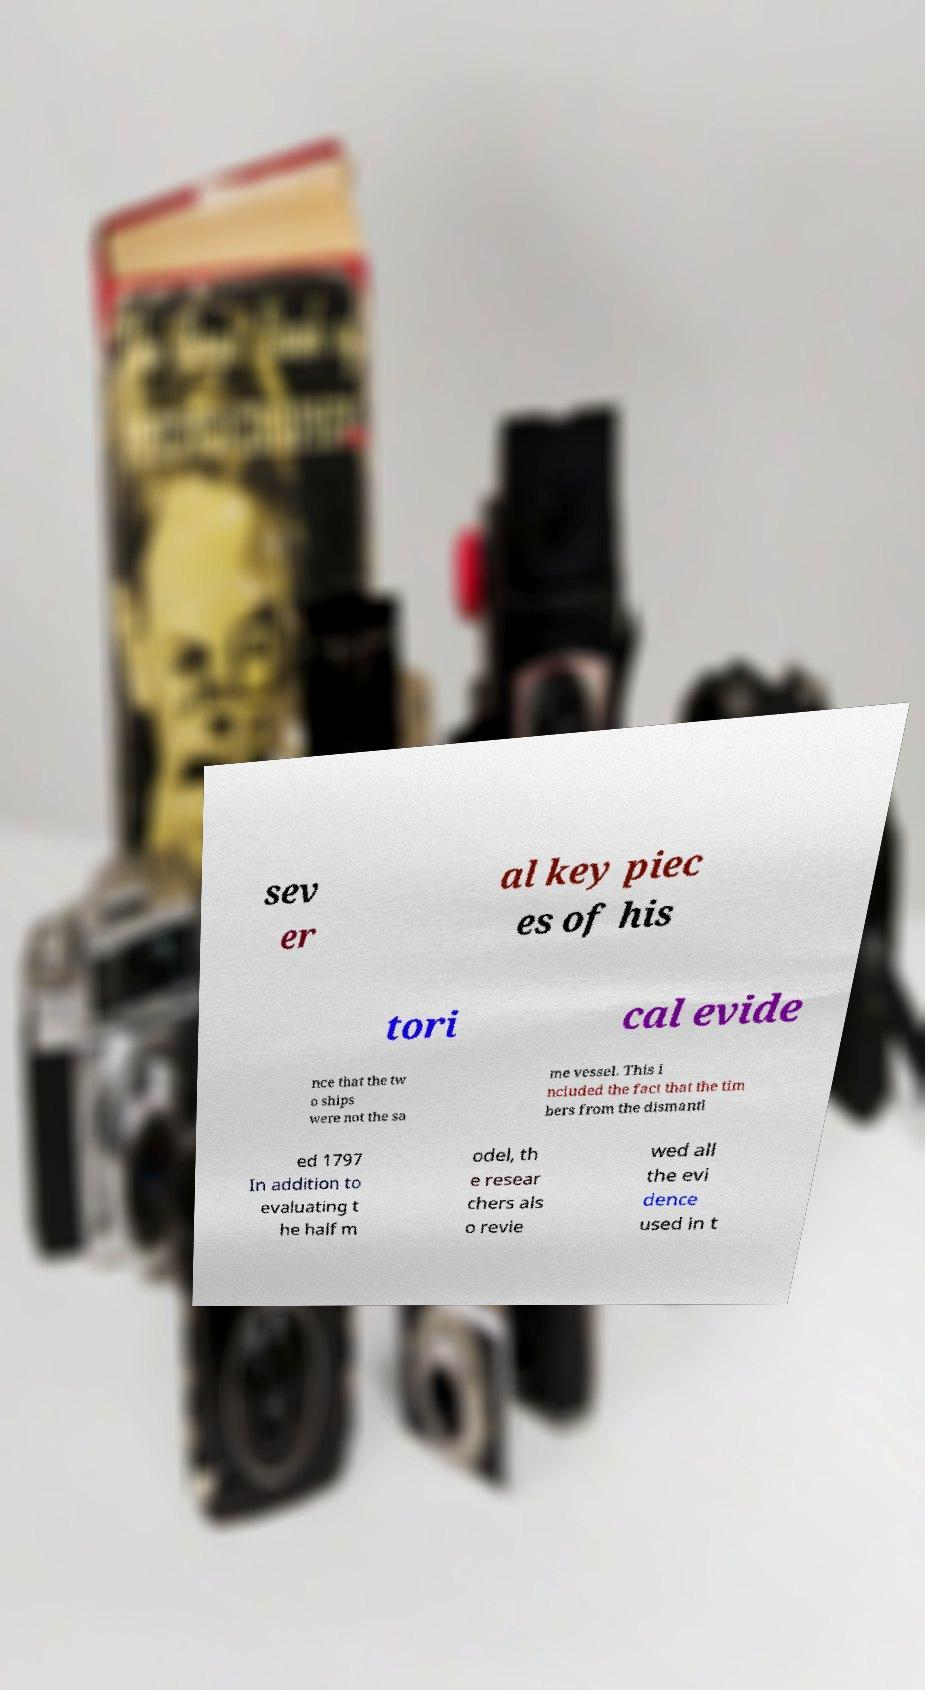Please read and relay the text visible in this image. What does it say? sev er al key piec es of his tori cal evide nce that the tw o ships were not the sa me vessel. This i ncluded the fact that the tim bers from the dismantl ed 1797 In addition to evaluating t he half m odel, th e resear chers als o revie wed all the evi dence used in t 